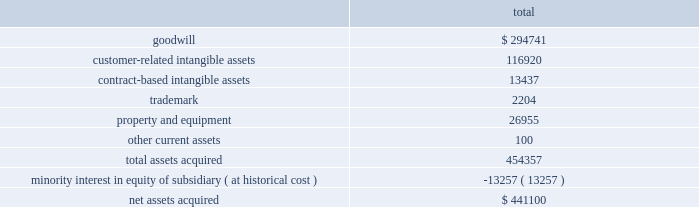Notes to consolidated financial statements 2014 ( continued ) merchant acquiring business in the united kingdom to the partnership .
In addition , hsbc uk entered into a ten-year marketing alliance with the partnership in which hsbc uk will refer customers to the partnership for payment processing services in the united kingdom .
On june 23 , 2008 , we entered into a new five year , $ 200 million term loan to fund a portion of the acquisition .
We funded the remaining purchase price with excess cash and our existing credit facilities .
The term loan bears interest , at our election , at the prime rate or london interbank offered rate plus a margin based on our leverage position .
As of july 1 , 2008 , the interest rate on the term loan was 3.605% ( 3.605 % ) .
The term loan calls for quarterly principal payments of $ 5 million beginning with the quarter ending august 31 , 2008 and increasing to $ 10 million beginning with the quarter ending august 31 , 2010 and $ 15 million beginning with the quarter ending august 31 , 2011 .
The partnership agreement includes provisions pursuant to which hsbc uk may compel us to purchase , at fair value , additional membership units from hsbc uk ( the 201cput option 201d ) .
Hsbc uk may exercise the put option on the fifth anniversary of the closing of the acquisition and on each anniversary thereafter .
By exercising the put option , hsbc uk can require us to purchase , on an annual basis , up to 15% ( 15 % ) of the total membership units .
Additionally , on the tenth anniversary of closing and each tenth anniversary thereafter , hsbc uk may compel us to purchase all of their membership units at fair value .
While not redeemable until june 2013 , we estimate the maximum total redemption amount of the minority interest under the put option would be $ 421.4 million , as of may 31 , 2008 .
The purpose of this acquisition was to establish a presence in the united kingdom .
The key factors that contributed to the decision to make this acquisition include historical and prospective financial statement analysis and hsbc uk 2019s market share and retail presence in the united kingdom .
The purchase price was determined by analyzing the historical and prospective financial statements and applying relevant purchase price multiples .
The purchase price totaled $ 441.1 million , consisting of $ 438.6 million cash consideration plus $ 2.5 million of direct out of pocket costs .
The acquisition has been recorded using the purchase method of accounting , and , accordingly , the purchase price has been allocated to the assets acquired and liabilities assumed based on their estimated fair values at the date of acquisition .
The table summarizes the preliminary purchase price allocation: .
Due to the recent timing of the transaction , the allocation of the purchase price is preliminary .
All of the goodwill associated with the acquisition is expected to be deductible for tax purposes .
The customer-related intangible assets have amortization periods of up to 13 years .
The contract-based intangible assets have amortization periods of 7 years .
The trademark has an amortization period of 5 years. .
What is the total amount of principle payment paid from 2008 to 2011? 
Rationale: to find the total amount of payments one must check line 7 and added up all the years from 2008 to 2011 .
Computations: ((5 + 10) + (5 + 10))
Answer: 30.0. Notes to consolidated financial statements 2014 ( continued ) merchant acquiring business in the united kingdom to the partnership .
In addition , hsbc uk entered into a ten-year marketing alliance with the partnership in which hsbc uk will refer customers to the partnership for payment processing services in the united kingdom .
On june 23 , 2008 , we entered into a new five year , $ 200 million term loan to fund a portion of the acquisition .
We funded the remaining purchase price with excess cash and our existing credit facilities .
The term loan bears interest , at our election , at the prime rate or london interbank offered rate plus a margin based on our leverage position .
As of july 1 , 2008 , the interest rate on the term loan was 3.605% ( 3.605 % ) .
The term loan calls for quarterly principal payments of $ 5 million beginning with the quarter ending august 31 , 2008 and increasing to $ 10 million beginning with the quarter ending august 31 , 2010 and $ 15 million beginning with the quarter ending august 31 , 2011 .
The partnership agreement includes provisions pursuant to which hsbc uk may compel us to purchase , at fair value , additional membership units from hsbc uk ( the 201cput option 201d ) .
Hsbc uk may exercise the put option on the fifth anniversary of the closing of the acquisition and on each anniversary thereafter .
By exercising the put option , hsbc uk can require us to purchase , on an annual basis , up to 15% ( 15 % ) of the total membership units .
Additionally , on the tenth anniversary of closing and each tenth anniversary thereafter , hsbc uk may compel us to purchase all of their membership units at fair value .
While not redeemable until june 2013 , we estimate the maximum total redemption amount of the minority interest under the put option would be $ 421.4 million , as of may 31 , 2008 .
The purpose of this acquisition was to establish a presence in the united kingdom .
The key factors that contributed to the decision to make this acquisition include historical and prospective financial statement analysis and hsbc uk 2019s market share and retail presence in the united kingdom .
The purchase price was determined by analyzing the historical and prospective financial statements and applying relevant purchase price multiples .
The purchase price totaled $ 441.1 million , consisting of $ 438.6 million cash consideration plus $ 2.5 million of direct out of pocket costs .
The acquisition has been recorded using the purchase method of accounting , and , accordingly , the purchase price has been allocated to the assets acquired and liabilities assumed based on their estimated fair values at the date of acquisition .
The table summarizes the preliminary purchase price allocation: .
Due to the recent timing of the transaction , the allocation of the purchase price is preliminary .
All of the goodwill associated with the acquisition is expected to be deductible for tax purposes .
The customer-related intangible assets have amortization periods of up to 13 years .
The contract-based intangible assets have amortization periods of 7 years .
The trademark has an amortization period of 5 years. .
What is the interest expense of the loan for the first quarter? 
Computations: ((200 * 3.605%) / 4)
Answer: 1.8025. 